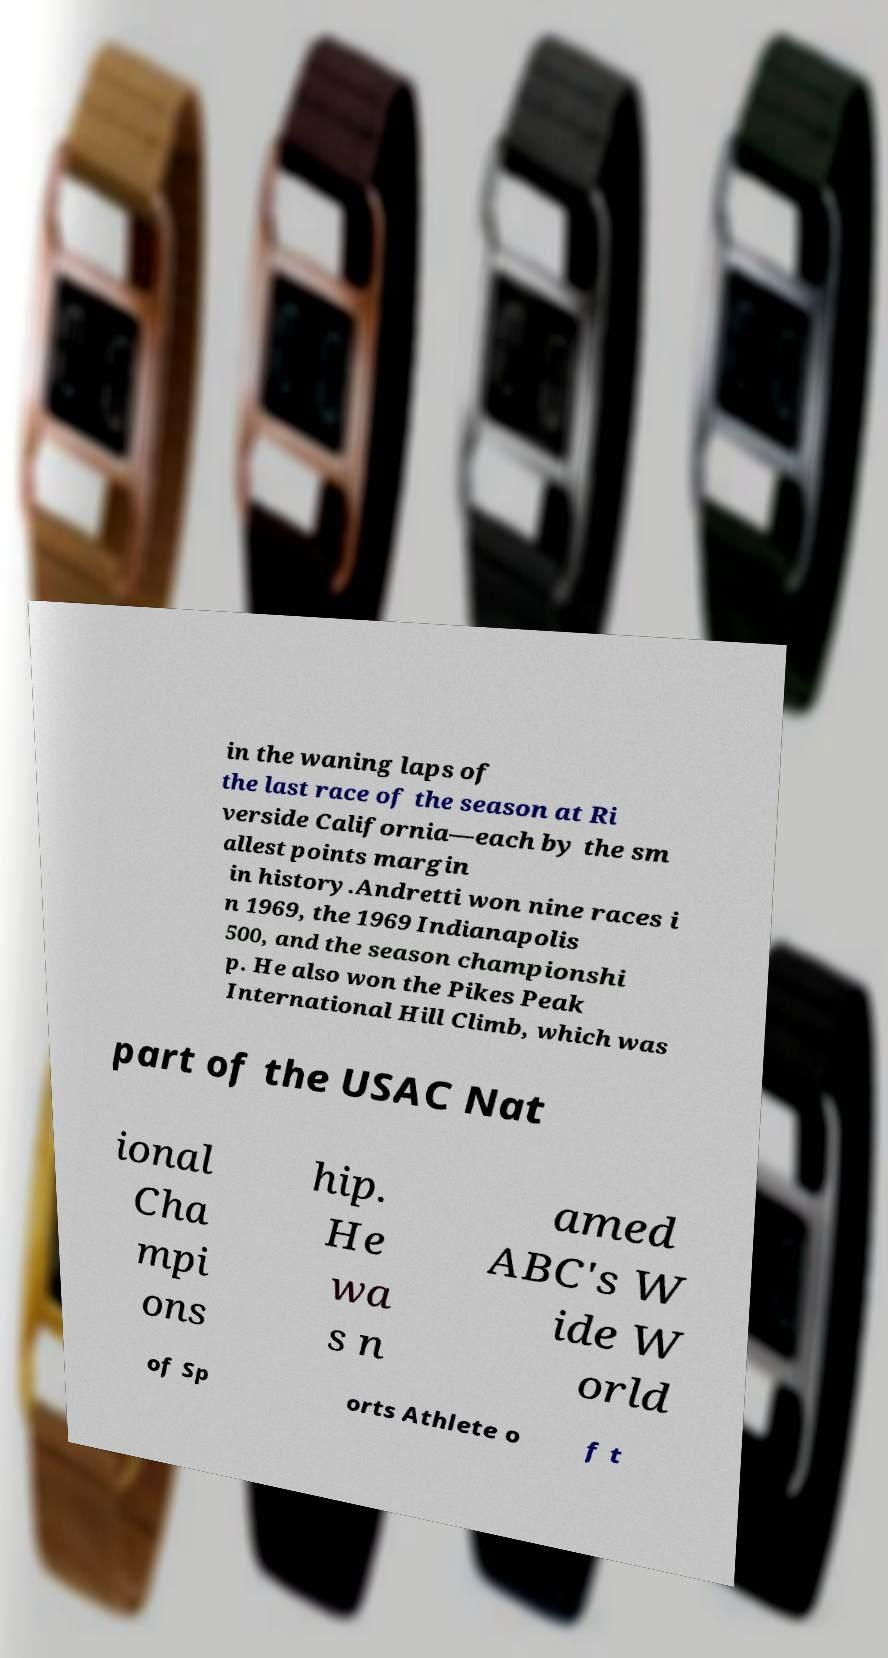Please identify and transcribe the text found in this image. in the waning laps of the last race of the season at Ri verside California—each by the sm allest points margin in history.Andretti won nine races i n 1969, the 1969 Indianapolis 500, and the season championshi p. He also won the Pikes Peak International Hill Climb, which was part of the USAC Nat ional Cha mpi ons hip. He wa s n amed ABC's W ide W orld of Sp orts Athlete o f t 